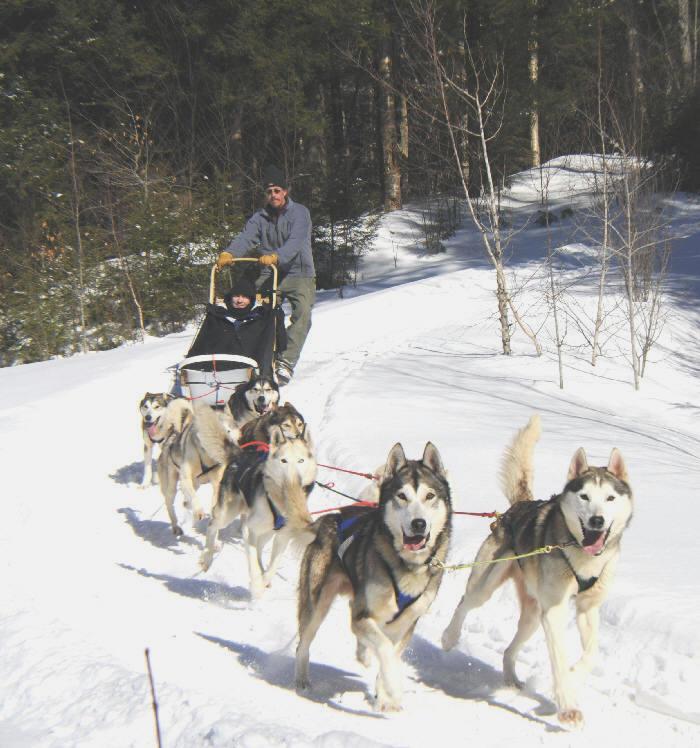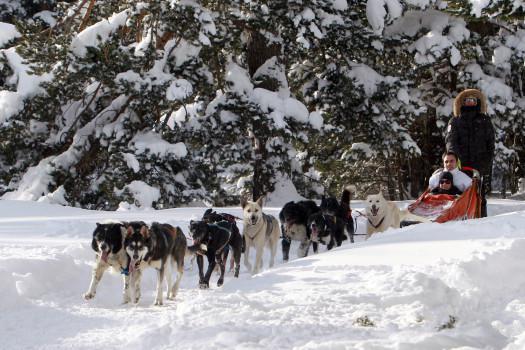The first image is the image on the left, the second image is the image on the right. For the images displayed, is the sentence "A sled driver in red and black leads a team of dogs diagonally to the left past stands of evergreen trees." factually correct? Answer yes or no. No. The first image is the image on the left, the second image is the image on the right. Evaluate the accuracy of this statement regarding the images: "All the sled dogs in the left image are running towards the left.". Is it true? Answer yes or no. No. 